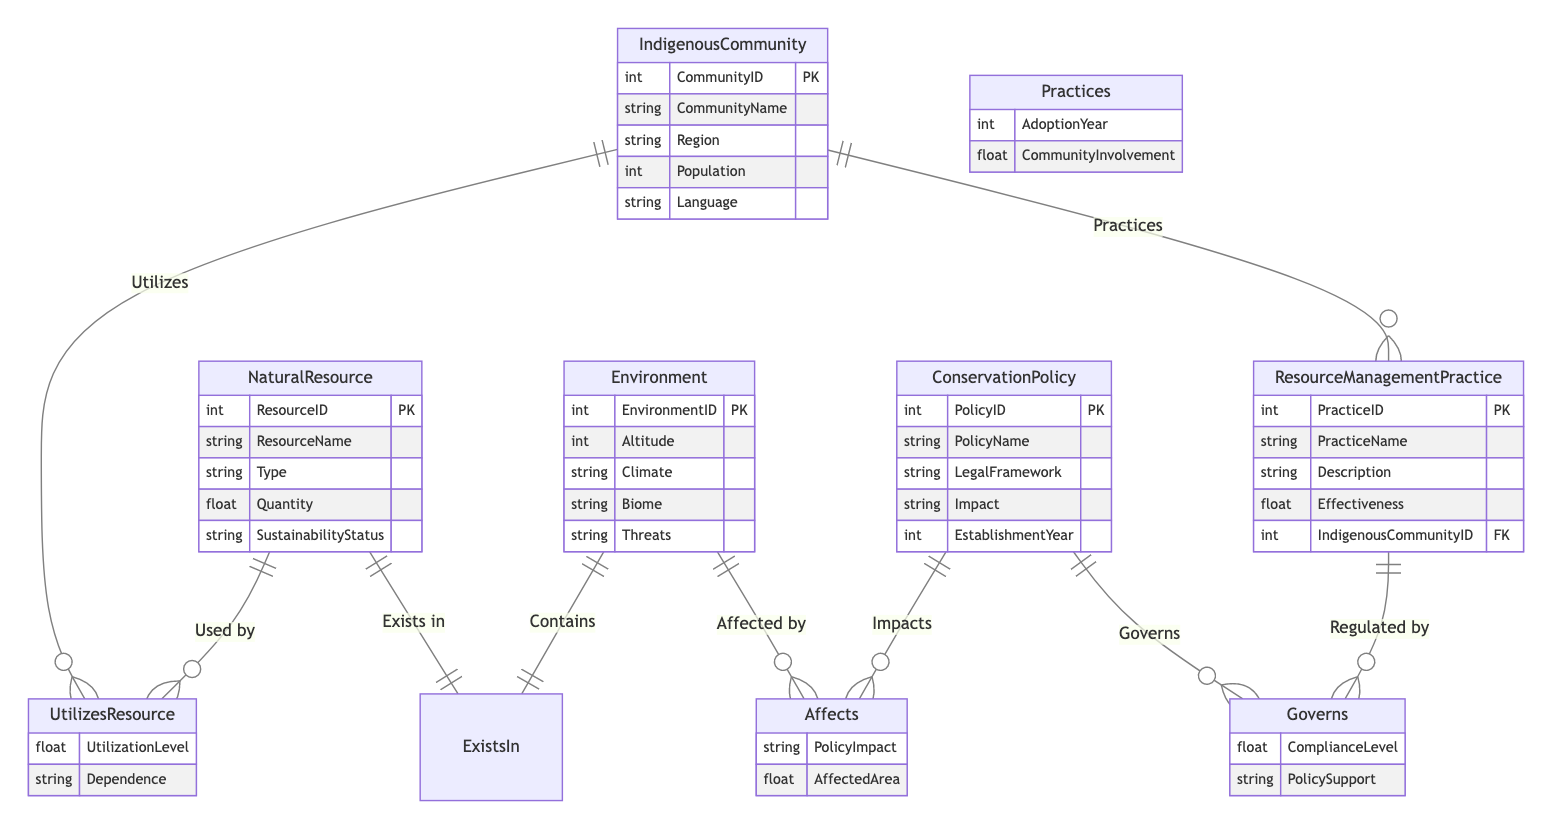What's the primary identifier for an Indigenous Community? The primary identifier for an Indigenous Community in this diagram is the "CommunityID", which serves as the primary key for the IndigenousCommunity entity.
Answer: CommunityID How many attributes does the Natural Resource entity have? The Natural Resource entity contains five attributes: ResourceID, ResourceName, Type, Quantity, and SustainabilityStatus. Thus, the total count of attributes is five.
Answer: Five What is the relationship connecting Conservation Policy and Environment? The relationship between Conservation Policy and Environment is "Affects," which indicates that the conservation policies have an impact on the environment.
Answer: Affects Which entity describes management practices? The entity that describes management practices is "ResourceManagementPractice," which includes several attributes like PracticeID, PracticeName, and Effectiveness.
Answer: ResourceManagementPractice How many entities are there in the diagram? The diagram includes five entities: IndigenousCommunity, NaturalResource, Environment, ResourceManagementPractice, and ConservationPolicy, giving a total count of five entities.
Answer: Five What do Indigenous Communities utilize from Natural Resources? Indigenous Communities utilize Natural Resources as indicated by the relationship "UtilizesResource," which also specifies utilization level and dependence.
Answer: Natural Resources Which relationship connects Resource Management Practice to Indigenous Communities? The relationship that connects Resource Management Practice to Indigenous Communities is "Practices," indicating that communities engage in resource management practices.
Answer: Practices What does the 'Effectiveness' attribute measure in Resource Management Practice? The 'Effectiveness' attribute in Resource Management Practice measures how successful a specific management practice is, though its numeric value is determined based on specific criteria within the context.
Answer: Effectiveness How many sustainability statuses are there for Natural Resources? The Natural Resource entity includes one attribute called SustainabilityStatus, which implies that there is one sustainability status attribute, but the number of distinct statuses isn’t specified in the diagram.
Answer: One What type of relationship exists between Natural Resource and Environment? The relationship existing between Natural Resource and Environment is "ExistsIn," which shows the ecological context of natural resources within environments at different altitudes and climates.
Answer: ExistsIn 